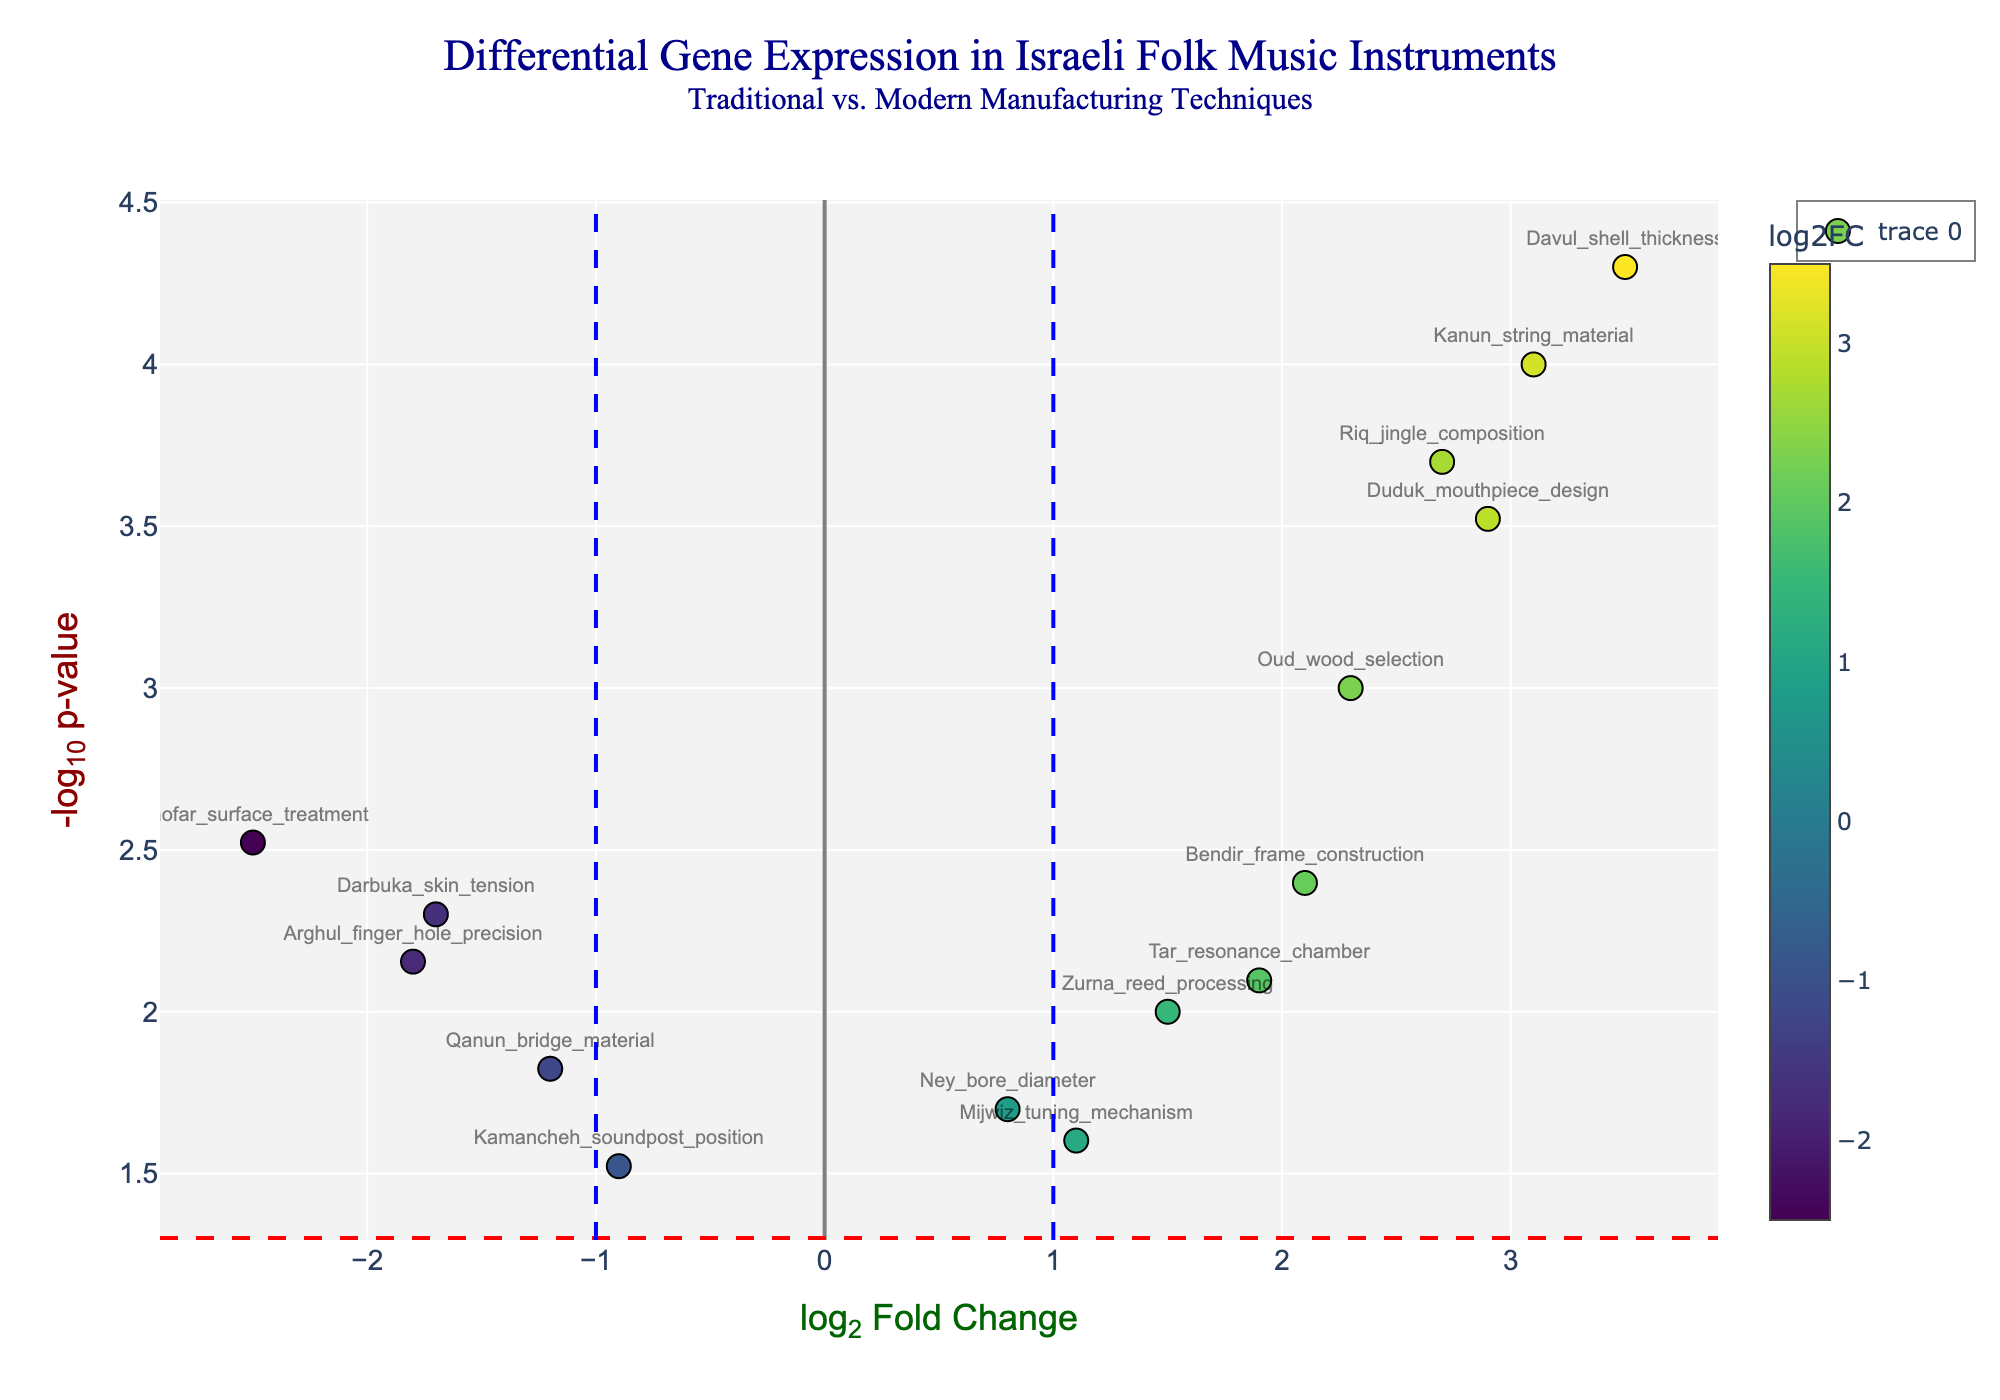What does the title of the plot indicate? The title explains that the plot is about differential gene expression in Israeli folk music instruments, comparing traditional and modern manufacturing techniques. This gives us the context of what the data represents.
Answer: Differential Gene Expression in Israeli Folk Music Instruments: Traditional vs. Modern Manufacturing Techniques How are the x-axis and y-axis labeled, and what do they represent? The x-axis is labeled "log2 Fold Change", which represents the fold change in gene expression between traditional and modern manufacturing techniques. The y-axis is labeled "-log10 p-value", representing the statistical significance of these changes.
Answer: x-axis: log2 Fold Change, y-axis: -log10 p-value Which gene shows the highest positive log2 fold change? To find this, look for the point with the highest value on the x-axis. The highest positive log2 fold change is for "Davul_shell_thickness" with a log2 Fold Change of 3.5.
Answer: Davul_shell_thickness Are there any genes with statistically significant changes at p-value < 0.05 near the vertical threshold lines (log2 fold change of ±1)? Look for points near the vertical lines at log2 fold change = ±1 and above the horizontal line indicating p-value < 0.05. For positive changes, "Ney_bore_diameter" and "Zurna_reed_processing" are near the threshold. For negative changes, "Qanun_bridge_material" and "Arghul_finger_hole_precision" are near the threshold.
Answer: Ney_bore_diameter, Zurna_reed_processing, Qanun_bridge_material, Arghul_finger_hole_precision Which gene is the most statistically significant in terms of p-value? The gene with the lowest p-value will have the highest value on the y-axis. "Davul_shell_thickness" has the highest -log10 p-value, indicating it is the most statistically significant.
Answer: Davul_shell_thickness How many genes have a log2 fold change greater than 2.0? Count the data points with a log2 fold change greater than 2.0. In this case, "Oud_wood_selection," "Kanun_string_material," "Riq_jingle_composition," "Bendir_frame_construction," "Duduk_mouthpiece_design," and "Davul_shell_thickness" meet this criterion, making it six genes.
Answer: 6 Compare the "Tar_resonance_chamber" and "Shofar_surface_treatment". Which has a higher statistical significance, and which has a higher fold change? First, compare their y-axis values for statistical significance: "Shofar_surface_treatment" has a higher -log10 p-value (more statistically significant). Next, compare their x-axis values for fold change: "Tar_resonance_chamber" has a higher log2 fold change.
Answer: "Shofar_surface_treatment" is more statistically significant, "Tar_resonance_chamber" has a higher fold change Which gene associated with string instruments shows a significant increase in expression (log2 fold change > 2) and has a p-value < 0.001? Check the genes related to string instruments. "Kanun_string_material" and "Duduk_mouthpiece_design" show significant increases in expression (log2 fold change > 2). Among these, "Kanun_string_material" has a p-value < 0.001.
Answer: Kanun_string_material 